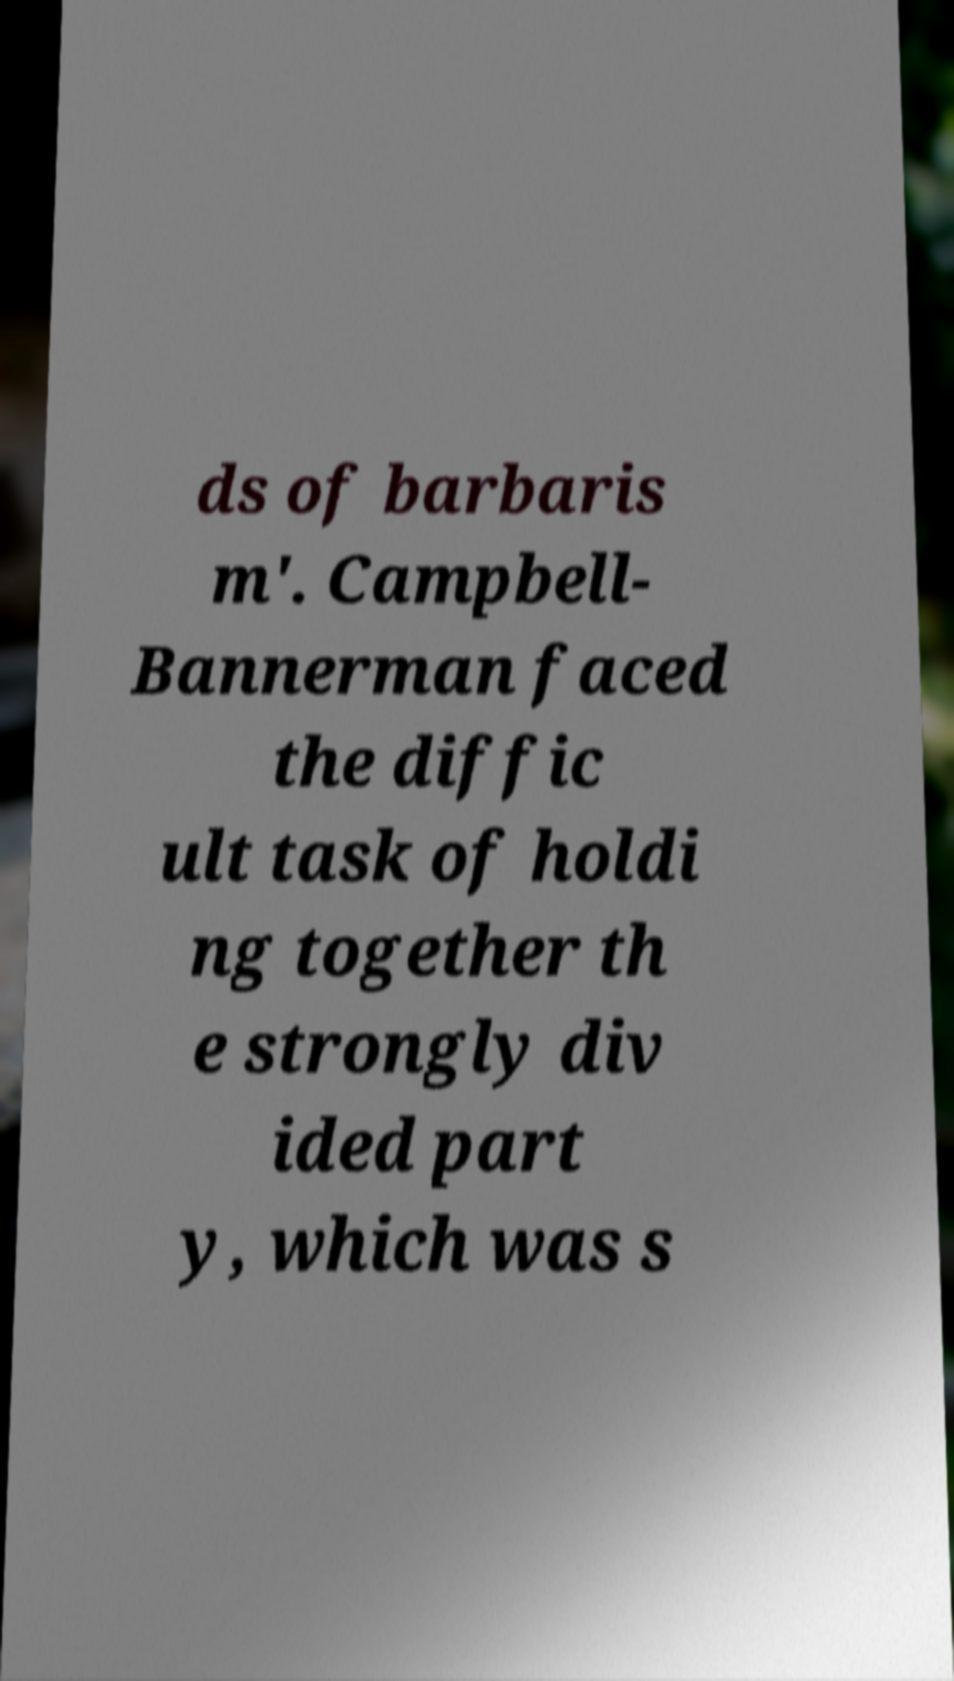Can you read and provide the text displayed in the image?This photo seems to have some interesting text. Can you extract and type it out for me? ds of barbaris m'. Campbell- Bannerman faced the diffic ult task of holdi ng together th e strongly div ided part y, which was s 